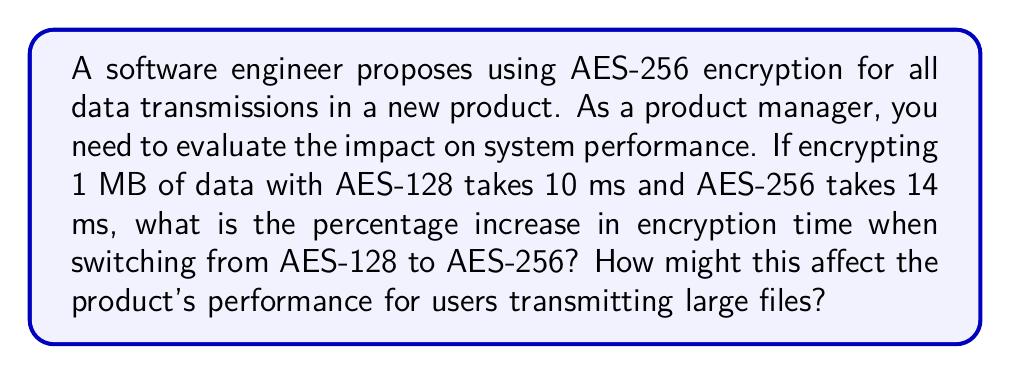Could you help me with this problem? To solve this problem, we need to follow these steps:

1. Calculate the difference in encryption time:
   $\text{Time difference} = \text{AES-256 time} - \text{AES-128 time}$
   $\text{Time difference} = 14 \text{ ms} - 10 \text{ ms} = 4 \text{ ms}$

2. Calculate the percentage increase:
   $$\text{Percentage increase} = \frac{\text{Time difference}}{\text{AES-128 time}} \times 100\%$$
   $$\text{Percentage increase} = \frac{4 \text{ ms}}{10 \text{ ms}} \times 100\% = 40\%$$

3. Analyze the impact on large file transmissions:
   For a 1 GB file (1024 MB), the additional encryption time would be:
   $$\text{Additional time} = 1024 \text{ MB} \times 4 \text{ ms/MB} = 4096 \text{ ms} = 4.096 \text{ seconds}$$

   This increased encryption time could lead to noticeable delays for users transmitting large files, potentially affecting the product's perceived performance and user experience.

4. Consider the trade-off:
   While AES-256 offers stronger security than AES-128, the 40% increase in encryption time represents a significant performance cost. As a product manager, you need to weigh this performance impact against the additional security benefits and consider factors such as:
   - The sensitivity of the data being transmitted
   - Regulatory requirements
   - User expectations for speed and security
   - Competitive landscape and industry standards
Answer: 40% increase in encryption time 